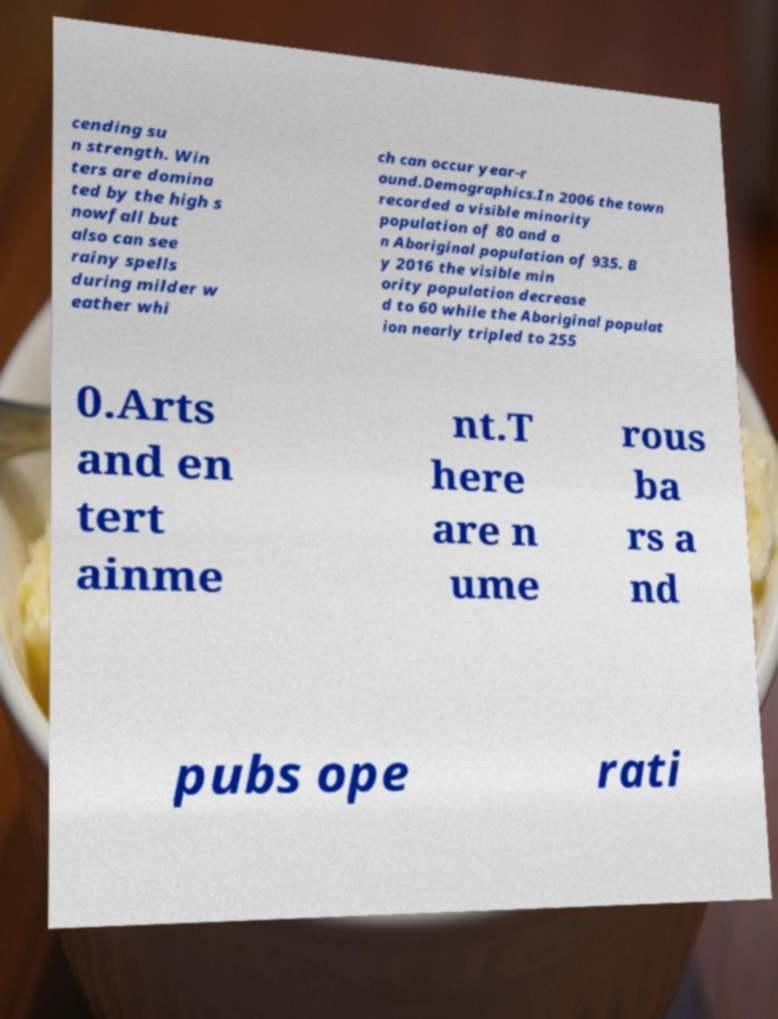For documentation purposes, I need the text within this image transcribed. Could you provide that? cending su n strength. Win ters are domina ted by the high s nowfall but also can see rainy spells during milder w eather whi ch can occur year-r ound.Demographics.In 2006 the town recorded a visible minority population of 80 and a n Aboriginal population of 935. B y 2016 the visible min ority population decrease d to 60 while the Aboriginal populat ion nearly tripled to 255 0.Arts and en tert ainme nt.T here are n ume rous ba rs a nd pubs ope rati 